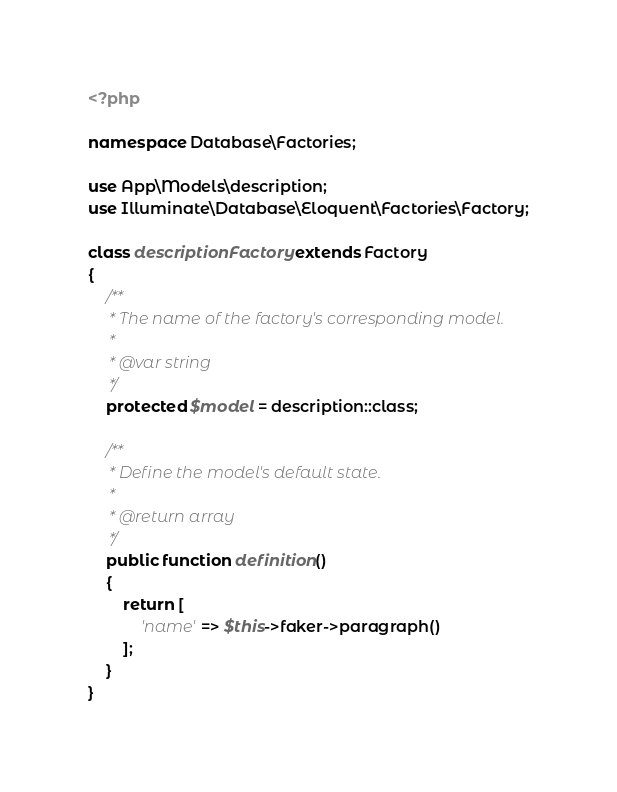<code> <loc_0><loc_0><loc_500><loc_500><_PHP_><?php

namespace Database\Factories;

use App\Models\description;
use Illuminate\Database\Eloquent\Factories\Factory;

class descriptionFactory extends Factory
{
    /**
     * The name of the factory's corresponding model.
     *
     * @var string
     */
    protected $model = description::class;

    /**
     * Define the model's default state.
     *
     * @return array
     */
    public function definition()
    {
        return [
            'name' => $this->faker->paragraph()
        ];
    }
}
</code> 